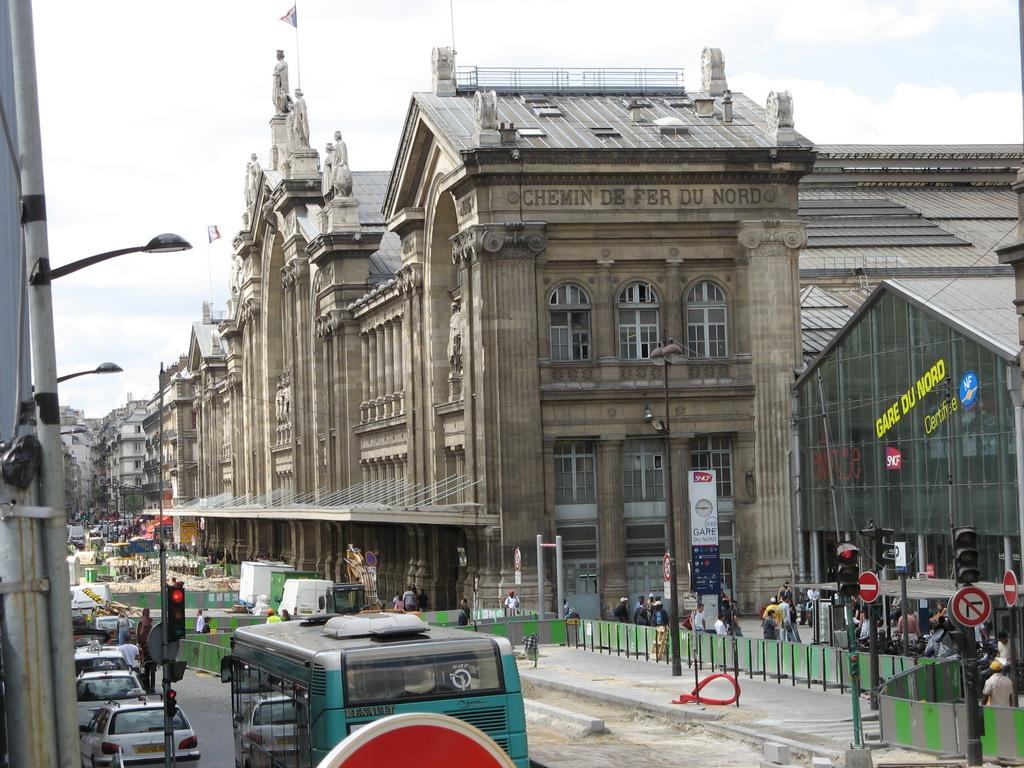What type of structures can be seen in the image? There are buildings in the image. What are the flags attached to in the image? The flags are attached to poles in the image. What can be found on the poles in the image? There are sign boards and traffic signals on the poles in the image. Are there any vehicles in the image? Yes, there is a bus in the image. What might be used for displaying information or advertisements in the image? The sign boards in the image can be used for displaying information or advertisements. What is visible in the sky in the image? The sky is visible in the image, and there are clouds present. Can you describe the people in the image? There are persons in the image, but their specific actions or characteristics are not mentioned in the provided facts. What type of cord is being used to tie the father's knot in the image? There is no mention of a father or a knot in the image; the facts provided do not include any information about these topics. 